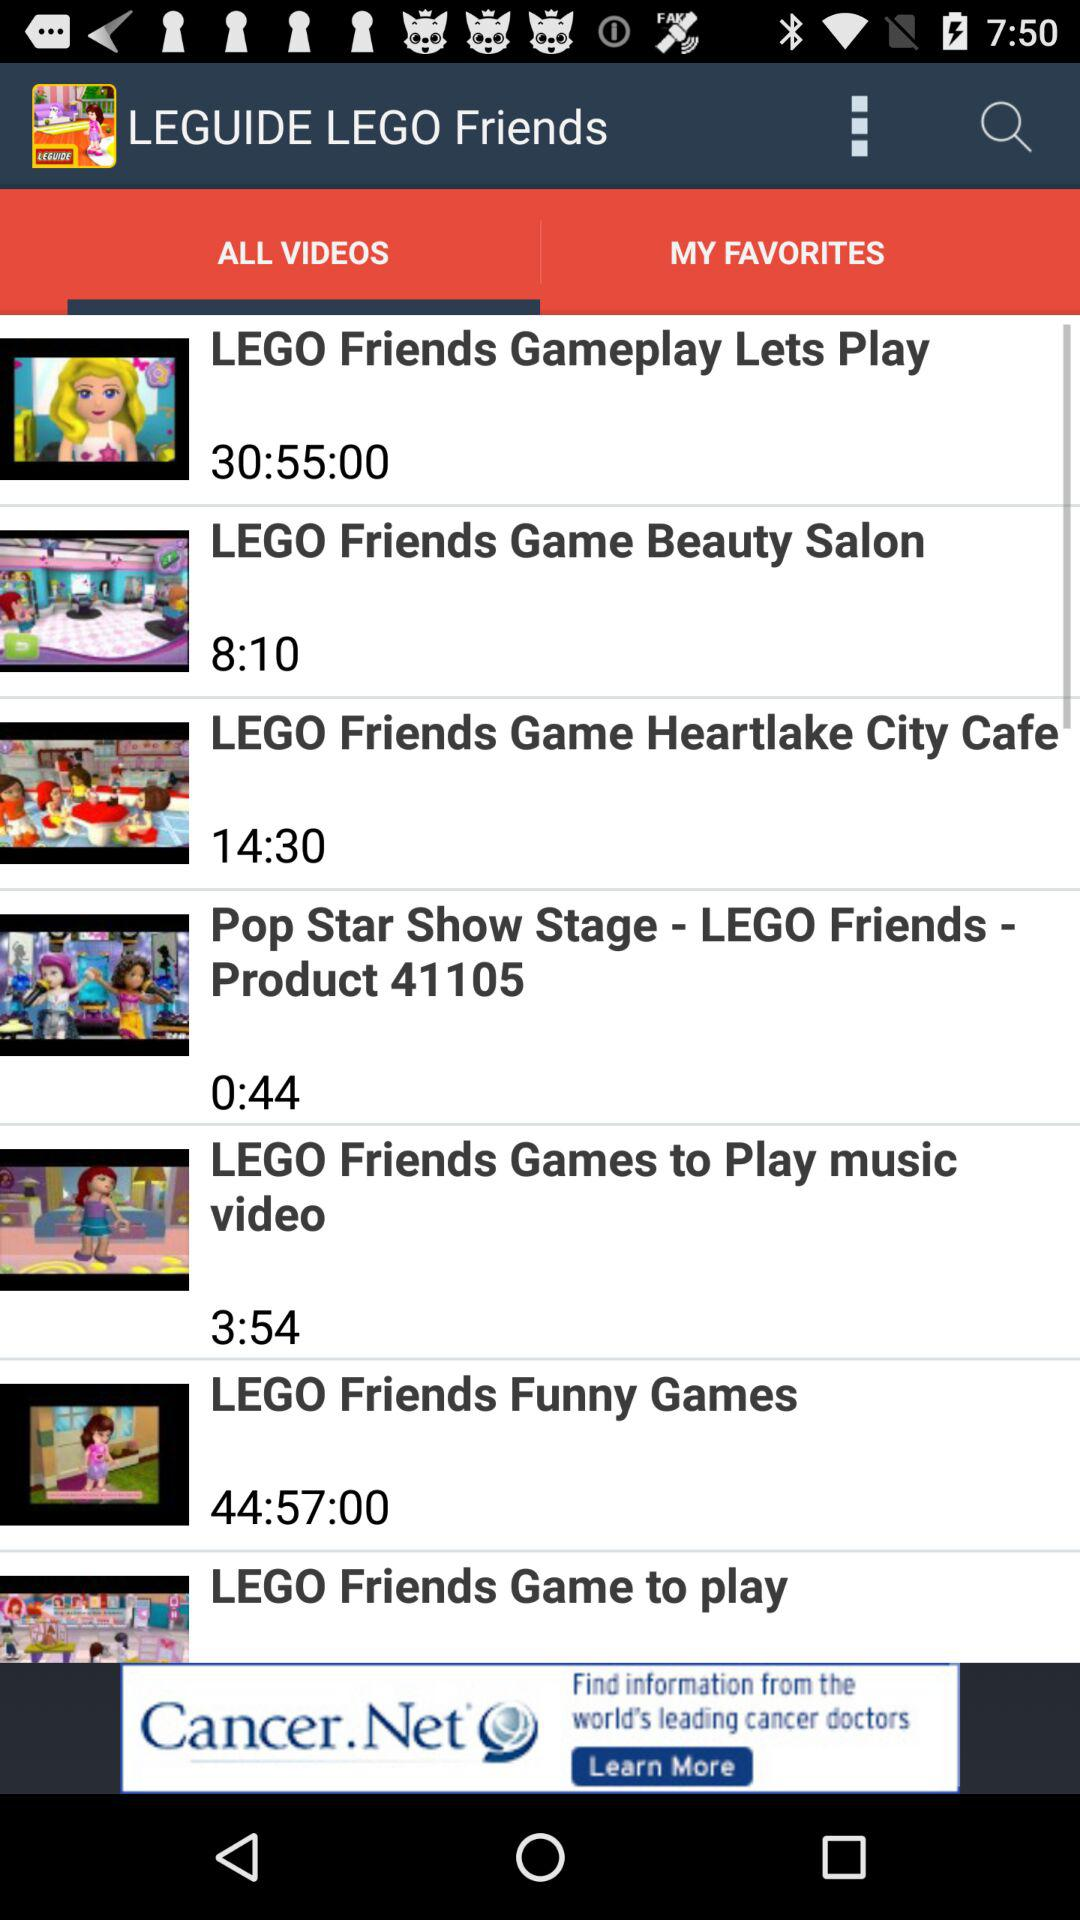What is the duration of "LEGO Friends Game Beauty Salon" video? The duration is 8 minutes 10 seconds. 